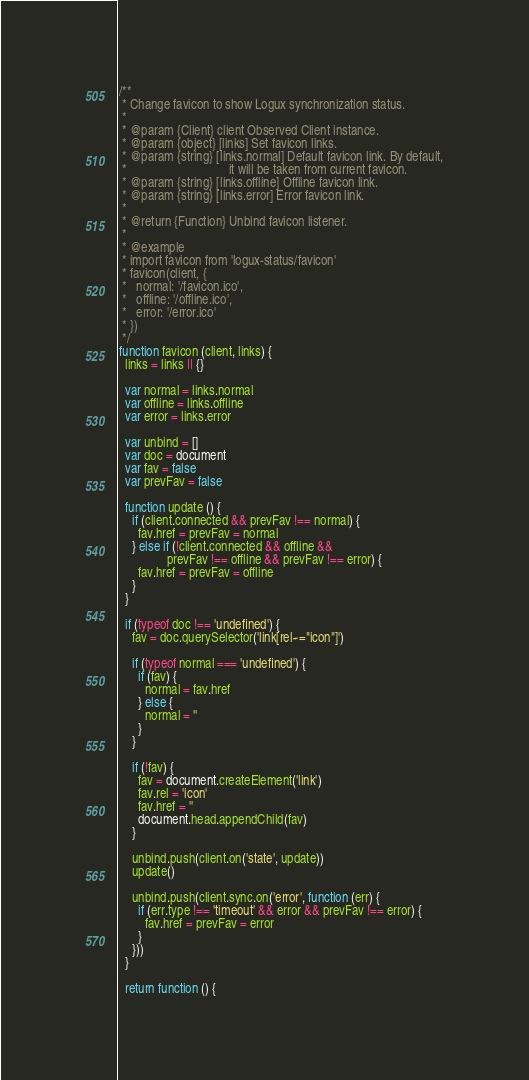Convert code to text. <code><loc_0><loc_0><loc_500><loc_500><_JavaScript_>/**
 * Change favicon to show Logux synchronization status.
 *
 * @param {Client} client Observed Client instance.
 * @param {object} [links] Set favicon links.
 * @param {string} [links.normal] Default favicon link. By default,
 *                                it will be taken from current favicon.
 * @param {string} [links.offline] Offline favicon link.
 * @param {string} [links.error] Error favicon link.
 *
 * @return {Function} Unbind favicon listener.
 *
 * @example
 * import favicon from 'logux-status/favicon'
 * favicon(client, {
 *   normal: '/favicon.ico',
 *   offline: '/offline.ico',
 *   error: '/error.ico'
 * })
 */
function favicon (client, links) {
  links = links || {}

  var normal = links.normal
  var offline = links.offline
  var error = links.error

  var unbind = []
  var doc = document
  var fav = false
  var prevFav = false

  function update () {
    if (client.connected && prevFav !== normal) {
      fav.href = prevFav = normal
    } else if (!client.connected && offline &&
               prevFav !== offline && prevFav !== error) {
      fav.href = prevFav = offline
    }
  }

  if (typeof doc !== 'undefined') {
    fav = doc.querySelector('link[rel~="icon"]')

    if (typeof normal === 'undefined') {
      if (fav) {
        normal = fav.href
      } else {
        normal = ''
      }
    }

    if (!fav) {
      fav = document.createElement('link')
      fav.rel = 'icon'
      fav.href = ''
      document.head.appendChild(fav)
    }

    unbind.push(client.on('state', update))
    update()

    unbind.push(client.sync.on('error', function (err) {
      if (err.type !== 'timeout' && error && prevFav !== error) {
        fav.href = prevFav = error
      }
    }))
  }

  return function () {</code> 